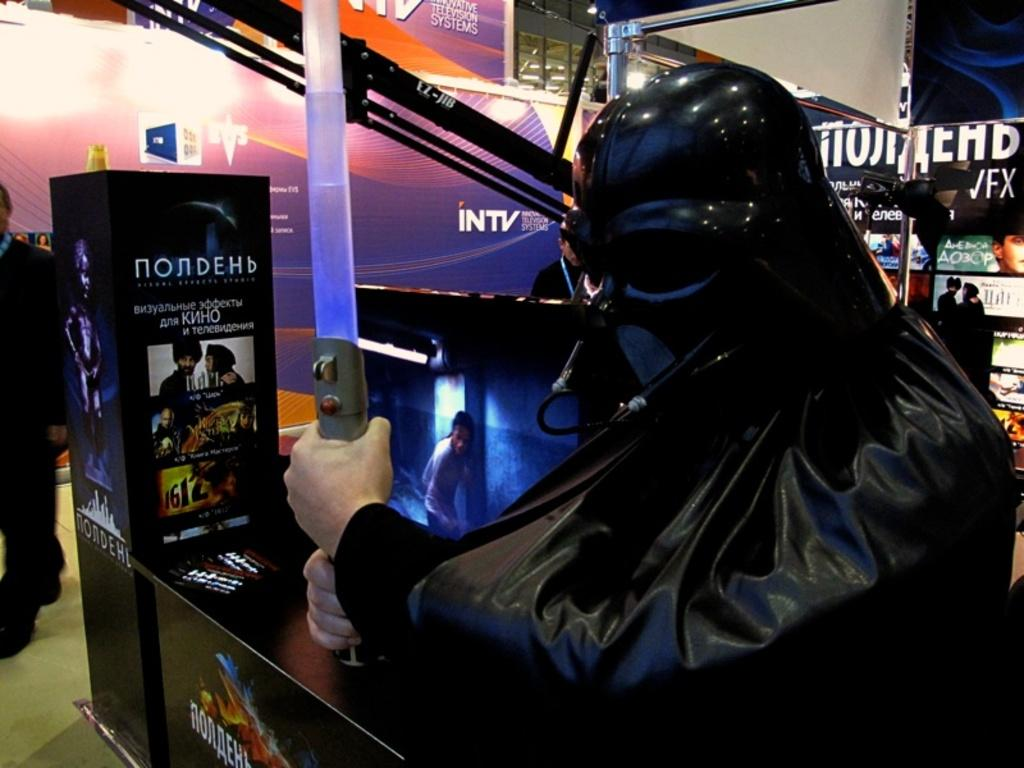What is the person in the image wearing? The person is wearing a costume in the image. What is the person holding in their hands? The person is holding a sword in their hands. What can be seen in the background of the image? There is a man on the floor and posters in the background of the image. What else is present in the background of the image? There are some objects in the background of the image. What type of alarm can be heard going off in the image? There is no alarm present or audible in the image. Is there a hose visible in the image? No, there is no hose present in the image. 